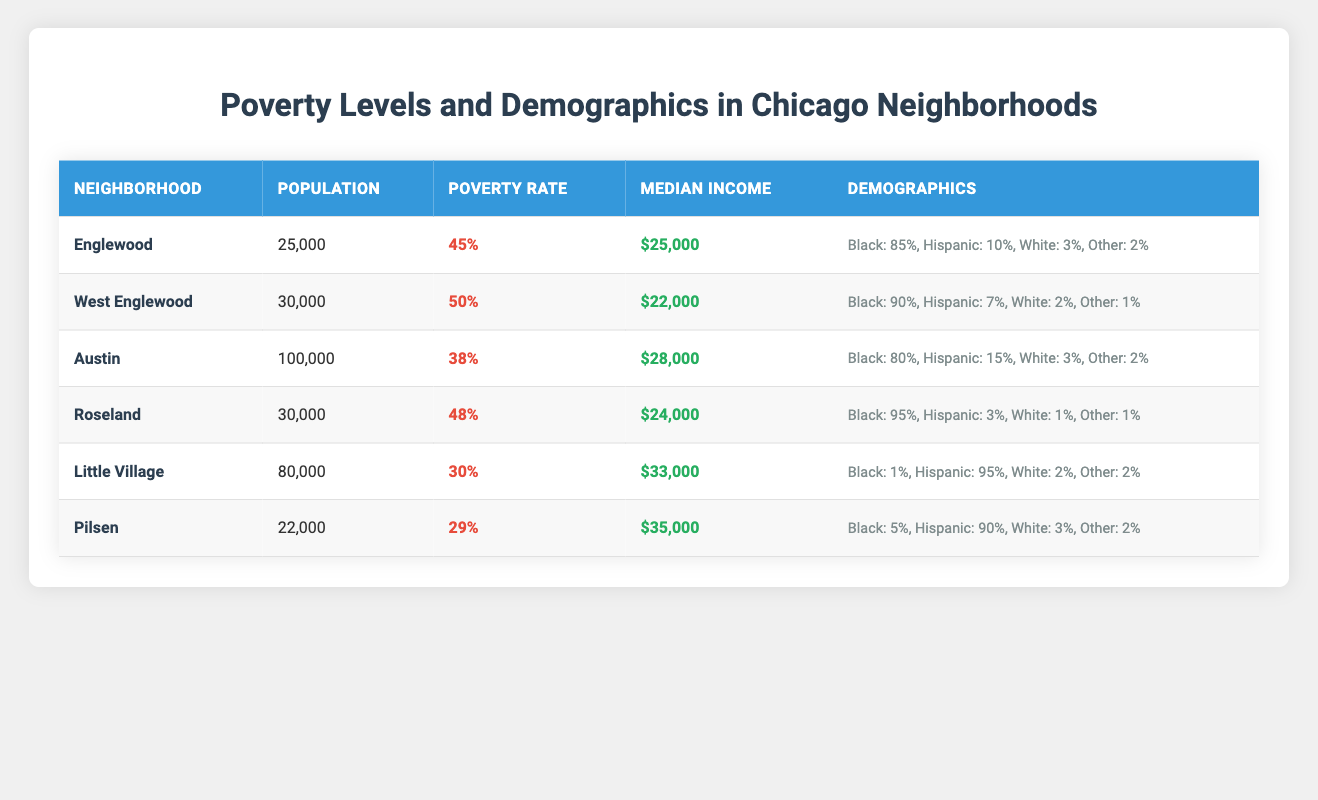What is the poverty rate in the Englewood neighborhood? From the table, the poverty rate for Englewood is listed as 45%.
Answer: 45% Which neighborhood has the highest median income? Looking at the median income values, Little Village has the highest median income at $33,000.
Answer: Little Village How many neighborhoods have a poverty rate higher than 40%? The neighborhoods with a poverty rate higher than 40% are Englewood (45%), West Englewood (50%), Austin (38%), and Roseland (48%), totaling four neighborhoods.
Answer: 4 What percentage of the population in Little Village is Hispanic? According to the demographics in the table, 95% of the population in Little Village identifies as Hispanic.
Answer: 95% Which neighborhood has the lowest poverty rate? The neighborhood with the lowest poverty rate is Pilsen, with a rate of 29%.
Answer: Pilsen What is the average median income of the neighborhoods listed? To find the average median income, we sum up all median incomes ($25,000 + $22,000 + $28,000 + $24,000 + $33,000 + $35,000 = $167,000) and divide by 6. The average is $167,000 / 6 = $27,833.
Answer: $27,833 True or False: West Englewood has a higher poverty rate than Austin. The table shows West Englewood with a poverty rate of 50% and Austin with a poverty rate of 38%, so the statement is true.
Answer: True What is the total population across all neighborhoods? To find the total population, add all populations: 25,000 + 30,000 + 100,000 + 30,000 + 80,000 + 22,000 = 287,000.
Answer: 287,000 Which demographic group constitutes the majority in Roseland? From the demographics data, 95% of the population in Roseland is Black, making it the majority demographic group.
Answer: Black How does the poverty rate of Pilsen compare to that of Austin? Pilsen has a poverty rate of 29% while Austin has a poverty rate of 38%. Since 29% is less than 38%, Pilsen's rate is lower than Austin's.
Answer: Pilsen's rate is lower 